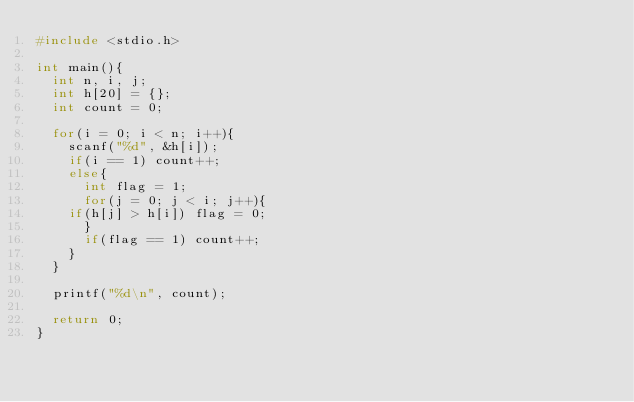Convert code to text. <code><loc_0><loc_0><loc_500><loc_500><_C_>#include <stdio.h>

int main(){
  int n, i, j;
  int h[20] = {};
  int count = 0;

  for(i = 0; i < n; i++){
    scanf("%d", &h[i]);
    if(i == 1) count++;
    else{
      int flag = 1;
      for(j = 0; j < i; j++){
	if(h[j] > h[i]) flag = 0;
      }
      if(flag == 1) count++;
    }
  }

  printf("%d\n", count);

  return 0;
}
       
</code> 